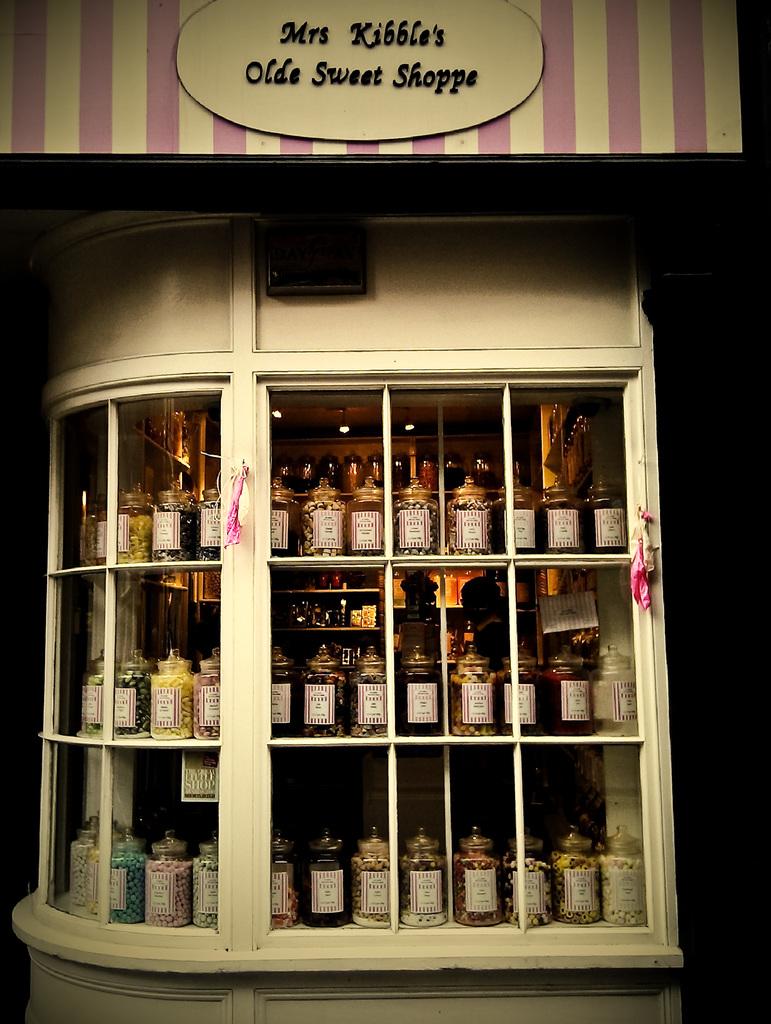What is the name of the shoppe?
Give a very brief answer. Mrs kibble's olde sweet shoppe. This is veskey bottles?
Provide a succinct answer. Yes. 